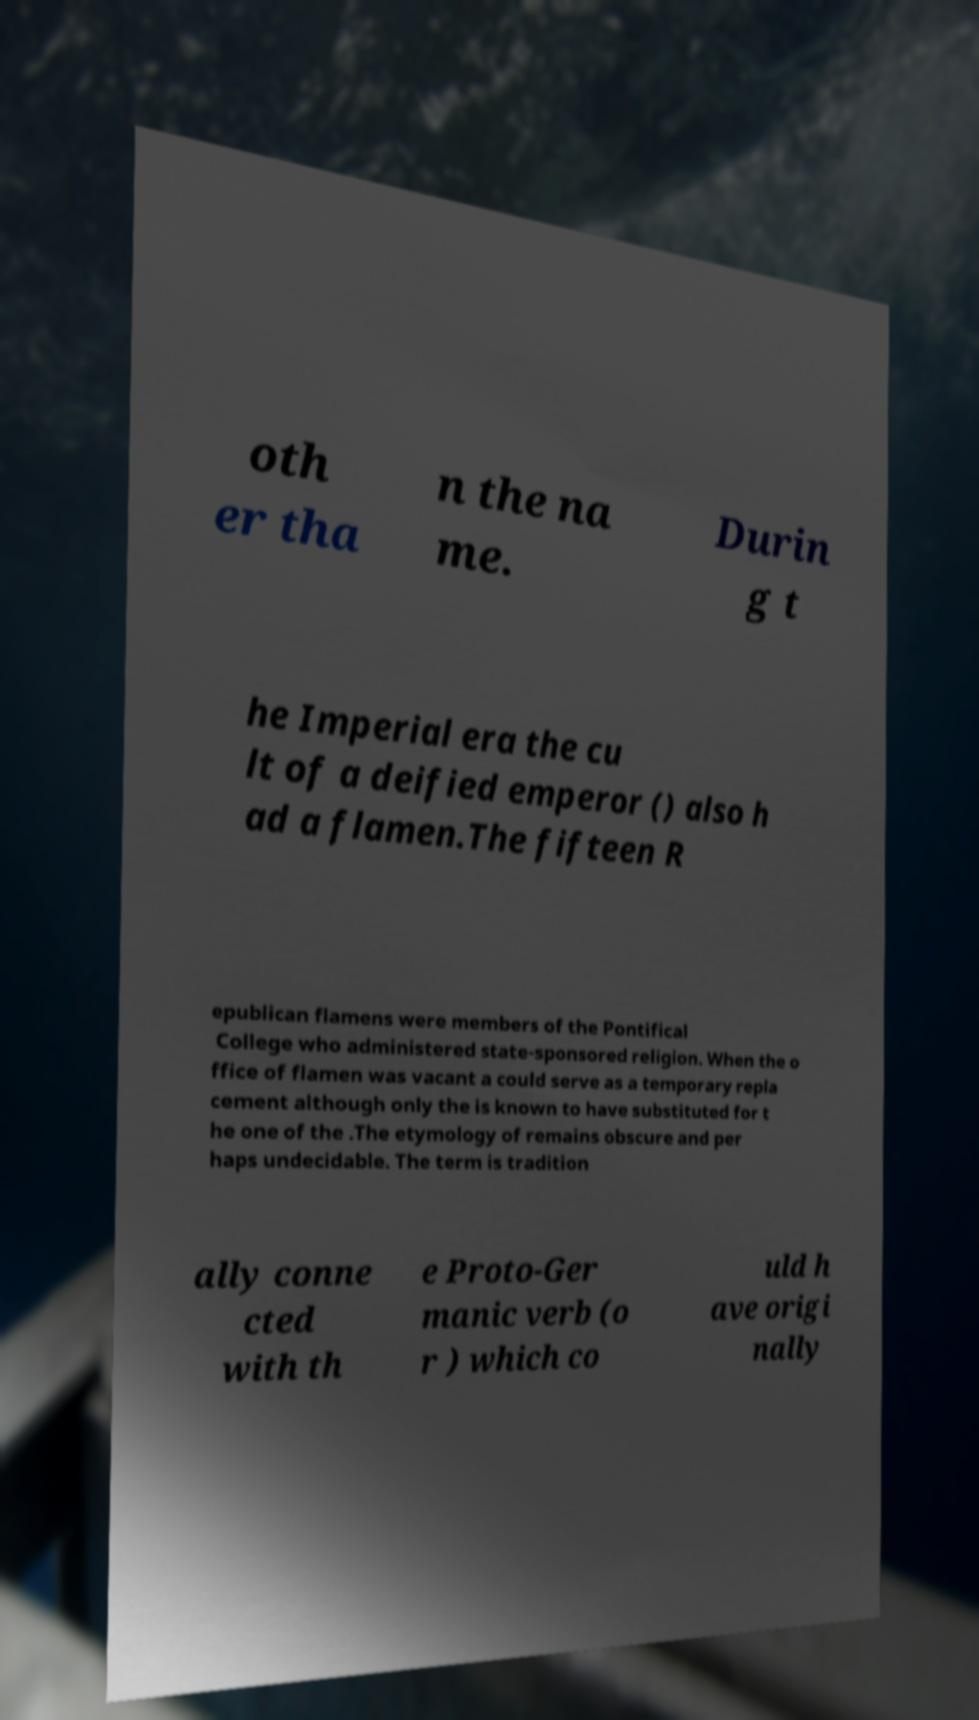Could you assist in decoding the text presented in this image and type it out clearly? oth er tha n the na me. Durin g t he Imperial era the cu lt of a deified emperor () also h ad a flamen.The fifteen R epublican flamens were members of the Pontifical College who administered state-sponsored religion. When the o ffice of flamen was vacant a could serve as a temporary repla cement although only the is known to have substituted for t he one of the .The etymology of remains obscure and per haps undecidable. The term is tradition ally conne cted with th e Proto-Ger manic verb (o r ) which co uld h ave origi nally 